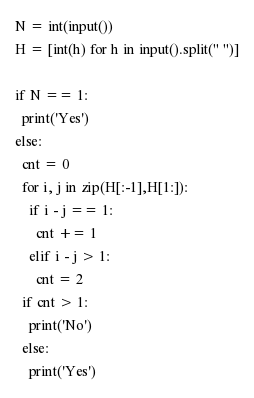Convert code to text. <code><loc_0><loc_0><loc_500><loc_500><_Python_>N = int(input())
H = [int(h) for h in input().split(" ")]

if N == 1:
  print('Yes')
else:
  cnt = 0
  for i, j in zip(H[:-1],H[1:]):
    if i - j == 1:
      cnt += 1
    elif i - j > 1:
      cnt = 2
  if cnt > 1:
    print('No')
  else:
    print('Yes')</code> 